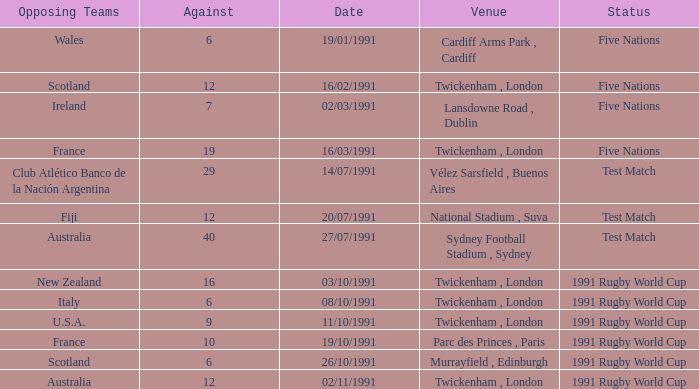What is Against, when Opposing Teams is "Australia", and when Date is "27/07/1991"? 40.0. 